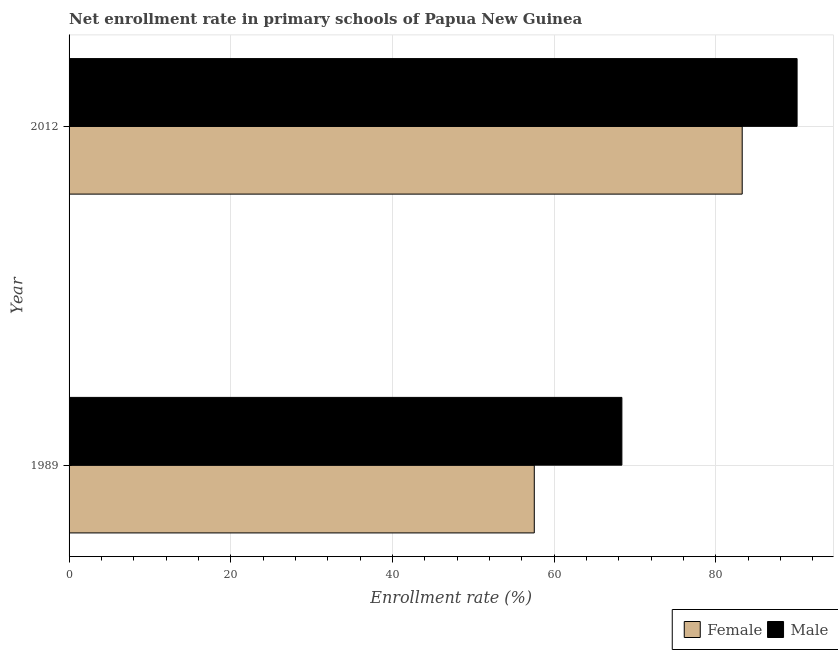What is the enrollment rate of male students in 2012?
Offer a very short reply. 90.05. Across all years, what is the maximum enrollment rate of male students?
Ensure brevity in your answer.  90.05. Across all years, what is the minimum enrollment rate of male students?
Your response must be concise. 68.38. In which year was the enrollment rate of female students minimum?
Provide a short and direct response. 1989. What is the total enrollment rate of male students in the graph?
Give a very brief answer. 158.43. What is the difference between the enrollment rate of female students in 1989 and that in 2012?
Your answer should be very brief. -25.72. What is the difference between the enrollment rate of female students in 1989 and the enrollment rate of male students in 2012?
Your response must be concise. -32.51. What is the average enrollment rate of female students per year?
Make the answer very short. 70.4. In the year 2012, what is the difference between the enrollment rate of female students and enrollment rate of male students?
Your answer should be compact. -6.79. In how many years, is the enrollment rate of male students greater than 48 %?
Your response must be concise. 2. What is the ratio of the enrollment rate of male students in 1989 to that in 2012?
Ensure brevity in your answer.  0.76. What does the 2nd bar from the top in 1989 represents?
Keep it short and to the point. Female. What does the 1st bar from the bottom in 2012 represents?
Provide a short and direct response. Female. How many bars are there?
Your answer should be very brief. 4. Are all the bars in the graph horizontal?
Your answer should be compact. Yes. How many years are there in the graph?
Your answer should be very brief. 2. What is the difference between two consecutive major ticks on the X-axis?
Your response must be concise. 20. Are the values on the major ticks of X-axis written in scientific E-notation?
Keep it short and to the point. No. What is the title of the graph?
Ensure brevity in your answer.  Net enrollment rate in primary schools of Papua New Guinea. What is the label or title of the X-axis?
Make the answer very short. Enrollment rate (%). What is the Enrollment rate (%) in Female in 1989?
Keep it short and to the point. 57.54. What is the Enrollment rate (%) in Male in 1989?
Give a very brief answer. 68.38. What is the Enrollment rate (%) in Female in 2012?
Ensure brevity in your answer.  83.26. What is the Enrollment rate (%) of Male in 2012?
Offer a terse response. 90.05. Across all years, what is the maximum Enrollment rate (%) of Female?
Offer a terse response. 83.26. Across all years, what is the maximum Enrollment rate (%) of Male?
Keep it short and to the point. 90.05. Across all years, what is the minimum Enrollment rate (%) of Female?
Your answer should be compact. 57.54. Across all years, what is the minimum Enrollment rate (%) in Male?
Make the answer very short. 68.38. What is the total Enrollment rate (%) of Female in the graph?
Ensure brevity in your answer.  140.8. What is the total Enrollment rate (%) of Male in the graph?
Offer a terse response. 158.43. What is the difference between the Enrollment rate (%) of Female in 1989 and that in 2012?
Provide a succinct answer. -25.72. What is the difference between the Enrollment rate (%) in Male in 1989 and that in 2012?
Ensure brevity in your answer.  -21.67. What is the difference between the Enrollment rate (%) in Female in 1989 and the Enrollment rate (%) in Male in 2012?
Give a very brief answer. -32.51. What is the average Enrollment rate (%) of Female per year?
Make the answer very short. 70.4. What is the average Enrollment rate (%) in Male per year?
Offer a very short reply. 79.21. In the year 1989, what is the difference between the Enrollment rate (%) in Female and Enrollment rate (%) in Male?
Your response must be concise. -10.84. In the year 2012, what is the difference between the Enrollment rate (%) in Female and Enrollment rate (%) in Male?
Your answer should be compact. -6.79. What is the ratio of the Enrollment rate (%) in Female in 1989 to that in 2012?
Make the answer very short. 0.69. What is the ratio of the Enrollment rate (%) of Male in 1989 to that in 2012?
Keep it short and to the point. 0.76. What is the difference between the highest and the second highest Enrollment rate (%) in Female?
Ensure brevity in your answer.  25.72. What is the difference between the highest and the second highest Enrollment rate (%) of Male?
Your response must be concise. 21.67. What is the difference between the highest and the lowest Enrollment rate (%) of Female?
Offer a terse response. 25.72. What is the difference between the highest and the lowest Enrollment rate (%) of Male?
Your response must be concise. 21.67. 